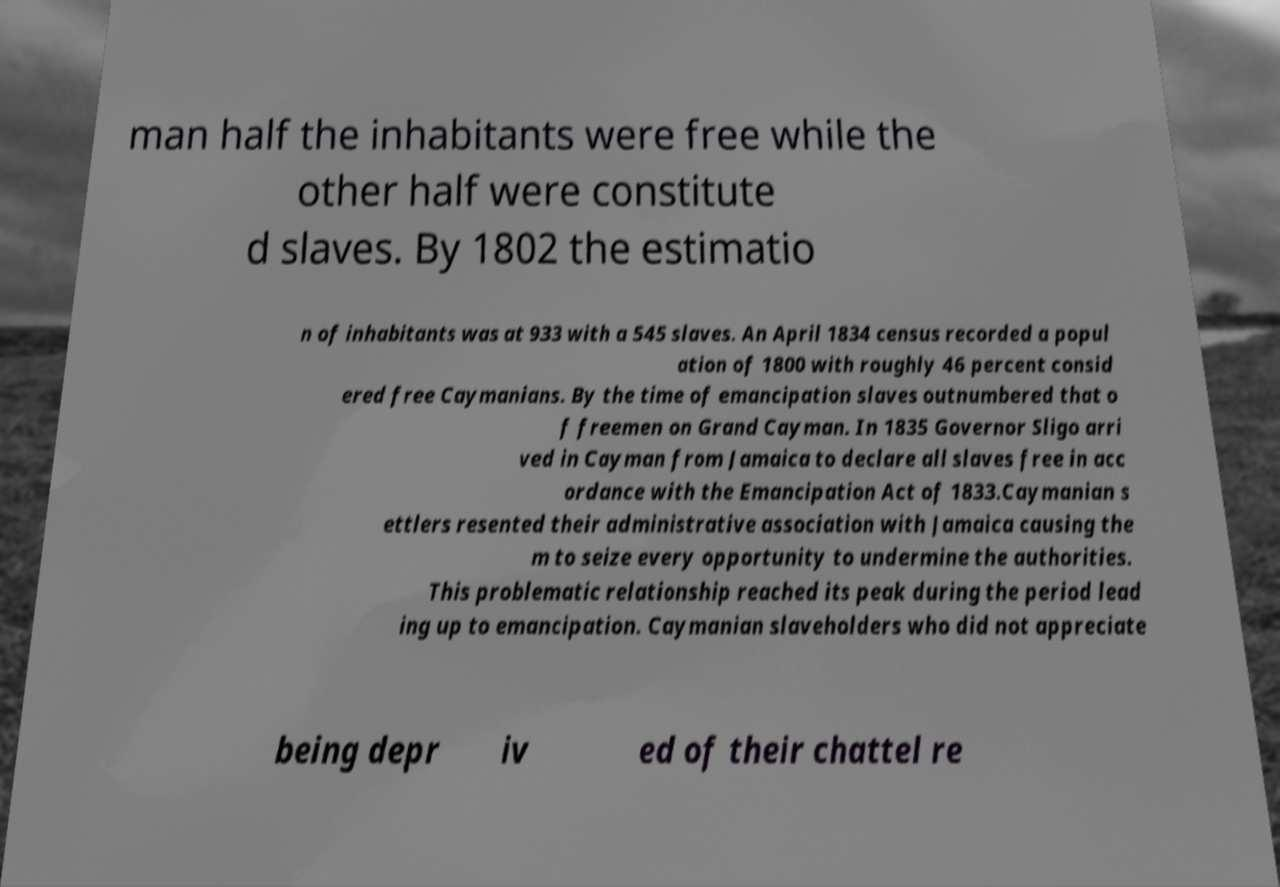Can you accurately transcribe the text from the provided image for me? man half the inhabitants were free while the other half were constitute d slaves. By 1802 the estimatio n of inhabitants was at 933 with a 545 slaves. An April 1834 census recorded a popul ation of 1800 with roughly 46 percent consid ered free Caymanians. By the time of emancipation slaves outnumbered that o f freemen on Grand Cayman. In 1835 Governor Sligo arri ved in Cayman from Jamaica to declare all slaves free in acc ordance with the Emancipation Act of 1833.Caymanian s ettlers resented their administrative association with Jamaica causing the m to seize every opportunity to undermine the authorities. This problematic relationship reached its peak during the period lead ing up to emancipation. Caymanian slaveholders who did not appreciate being depr iv ed of their chattel re 